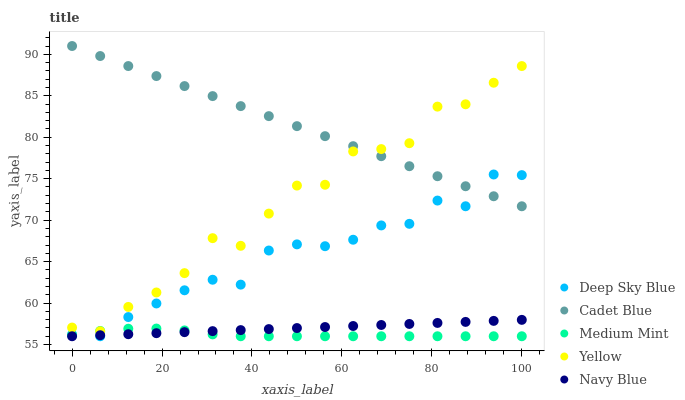Does Medium Mint have the minimum area under the curve?
Answer yes or no. Yes. Does Cadet Blue have the maximum area under the curve?
Answer yes or no. Yes. Does Navy Blue have the minimum area under the curve?
Answer yes or no. No. Does Navy Blue have the maximum area under the curve?
Answer yes or no. No. Is Cadet Blue the smoothest?
Answer yes or no. Yes. Is Yellow the roughest?
Answer yes or no. Yes. Is Navy Blue the smoothest?
Answer yes or no. No. Is Navy Blue the roughest?
Answer yes or no. No. Does Medium Mint have the lowest value?
Answer yes or no. Yes. Does Cadet Blue have the lowest value?
Answer yes or no. No. Does Cadet Blue have the highest value?
Answer yes or no. Yes. Does Navy Blue have the highest value?
Answer yes or no. No. Is Navy Blue less than Cadet Blue?
Answer yes or no. Yes. Is Cadet Blue greater than Medium Mint?
Answer yes or no. Yes. Does Navy Blue intersect Medium Mint?
Answer yes or no. Yes. Is Navy Blue less than Medium Mint?
Answer yes or no. No. Is Navy Blue greater than Medium Mint?
Answer yes or no. No. Does Navy Blue intersect Cadet Blue?
Answer yes or no. No. 